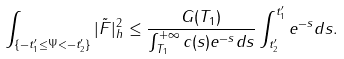Convert formula to latex. <formula><loc_0><loc_0><loc_500><loc_500>\int _ { \{ - t ^ { \prime } _ { 1 } \leq \Psi < - t ^ { \prime } _ { 2 } \} } | \tilde { F } | ^ { 2 } _ { h } \leq \frac { G ( T _ { 1 } ) } { \int _ { T _ { 1 } } ^ { + \infty } c ( s ) e ^ { - s } d s } \int _ { t ^ { \prime } _ { 2 } } ^ { t ^ { \prime } _ { 1 } } e ^ { - s } d s .</formula> 